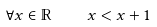Convert formula to latex. <formula><loc_0><loc_0><loc_500><loc_500>\forall x \in \mathbb { R } \quad x < x + 1</formula> 